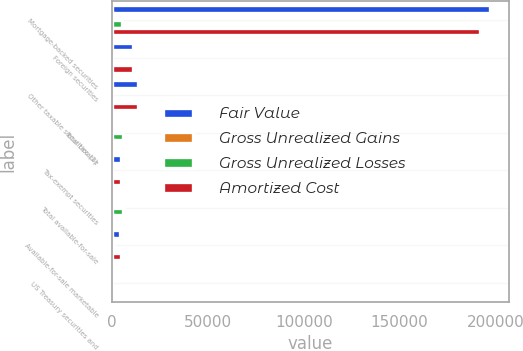<chart> <loc_0><loc_0><loc_500><loc_500><stacked_bar_chart><ecel><fcel>Mortgage-backed securities<fcel>Foreign securities<fcel>Other taxable securities (1)<fcel>Total taxable<fcel>Tax-exempt securities<fcel>Total available-for-sale<fcel>Available-for-sale marketable<fcel>US Treasury securities and<nl><fcel>Fair Value<fcel>197101<fcel>10944<fcel>13198<fcel>711.5<fcel>4693<fcel>711.5<fcel>4060<fcel>710<nl><fcel>Gross Unrealized Gains<fcel>198<fcel>1<fcel>126<fcel>325<fcel>31<fcel>356<fcel>305<fcel>5<nl><fcel>Gross Unrealized Losses<fcel>5268<fcel>54<fcel>99<fcel>5434<fcel>32<fcel>5466<fcel>18<fcel>2<nl><fcel>Amortized Cost<fcel>192031<fcel>10891<fcel>13225<fcel>711.5<fcel>4692<fcel>711.5<fcel>4347<fcel>713<nl></chart> 